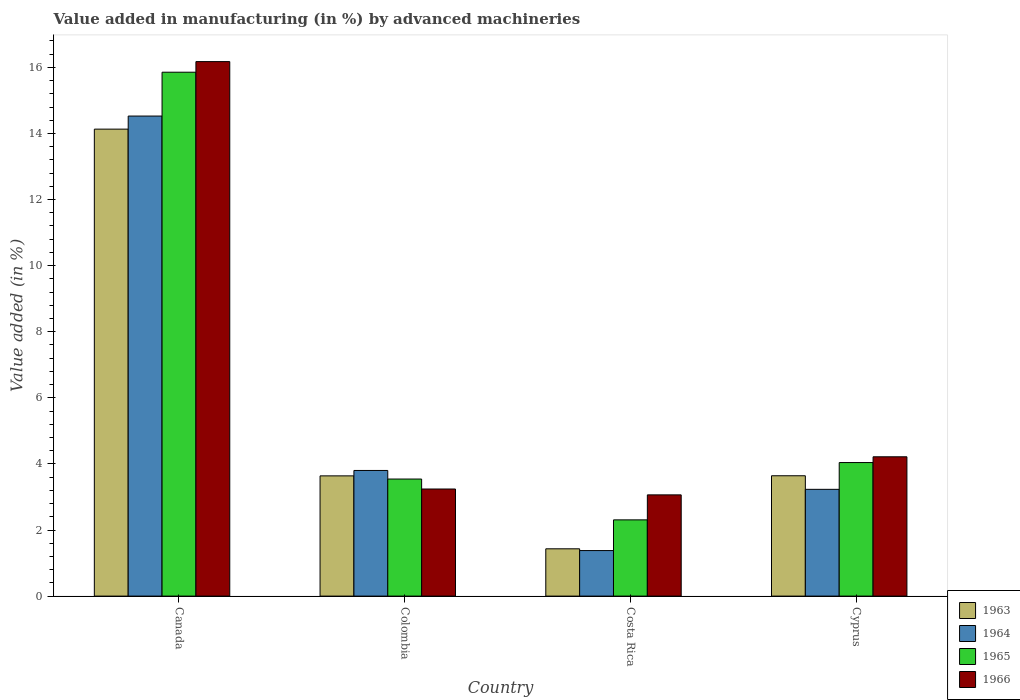Are the number of bars per tick equal to the number of legend labels?
Provide a succinct answer. Yes. Are the number of bars on each tick of the X-axis equal?
Your answer should be compact. Yes. What is the label of the 3rd group of bars from the left?
Offer a very short reply. Costa Rica. What is the percentage of value added in manufacturing by advanced machineries in 1965 in Colombia?
Keep it short and to the point. 3.54. Across all countries, what is the maximum percentage of value added in manufacturing by advanced machineries in 1966?
Keep it short and to the point. 16.17. Across all countries, what is the minimum percentage of value added in manufacturing by advanced machineries in 1964?
Keep it short and to the point. 1.38. In which country was the percentage of value added in manufacturing by advanced machineries in 1964 maximum?
Offer a terse response. Canada. What is the total percentage of value added in manufacturing by advanced machineries in 1964 in the graph?
Provide a short and direct response. 22.94. What is the difference between the percentage of value added in manufacturing by advanced machineries in 1966 in Costa Rica and that in Cyprus?
Your answer should be very brief. -1.15. What is the difference between the percentage of value added in manufacturing by advanced machineries in 1964 in Canada and the percentage of value added in manufacturing by advanced machineries in 1963 in Colombia?
Keep it short and to the point. 10.89. What is the average percentage of value added in manufacturing by advanced machineries in 1965 per country?
Give a very brief answer. 6.44. What is the difference between the percentage of value added in manufacturing by advanced machineries of/in 1965 and percentage of value added in manufacturing by advanced machineries of/in 1966 in Canada?
Ensure brevity in your answer.  -0.32. In how many countries, is the percentage of value added in manufacturing by advanced machineries in 1963 greater than 2 %?
Offer a very short reply. 3. What is the ratio of the percentage of value added in manufacturing by advanced machineries in 1966 in Colombia to that in Cyprus?
Make the answer very short. 0.77. Is the difference between the percentage of value added in manufacturing by advanced machineries in 1965 in Costa Rica and Cyprus greater than the difference between the percentage of value added in manufacturing by advanced machineries in 1966 in Costa Rica and Cyprus?
Provide a succinct answer. No. What is the difference between the highest and the second highest percentage of value added in manufacturing by advanced machineries in 1964?
Your answer should be compact. -0.57. What is the difference between the highest and the lowest percentage of value added in manufacturing by advanced machineries in 1964?
Make the answer very short. 13.15. In how many countries, is the percentage of value added in manufacturing by advanced machineries in 1966 greater than the average percentage of value added in manufacturing by advanced machineries in 1966 taken over all countries?
Your response must be concise. 1. Is it the case that in every country, the sum of the percentage of value added in manufacturing by advanced machineries in 1965 and percentage of value added in manufacturing by advanced machineries in 1966 is greater than the sum of percentage of value added in manufacturing by advanced machineries in 1963 and percentage of value added in manufacturing by advanced machineries in 1964?
Your response must be concise. No. What does the 1st bar from the right in Colombia represents?
Make the answer very short. 1966. How many bars are there?
Ensure brevity in your answer.  16. How many countries are there in the graph?
Provide a short and direct response. 4. Are the values on the major ticks of Y-axis written in scientific E-notation?
Provide a short and direct response. No. Does the graph contain any zero values?
Offer a very short reply. No. Does the graph contain grids?
Your answer should be compact. No. Where does the legend appear in the graph?
Provide a short and direct response. Bottom right. How many legend labels are there?
Provide a short and direct response. 4. What is the title of the graph?
Offer a very short reply. Value added in manufacturing (in %) by advanced machineries. Does "2012" appear as one of the legend labels in the graph?
Offer a terse response. No. What is the label or title of the Y-axis?
Offer a very short reply. Value added (in %). What is the Value added (in %) of 1963 in Canada?
Keep it short and to the point. 14.13. What is the Value added (in %) in 1964 in Canada?
Give a very brief answer. 14.53. What is the Value added (in %) of 1965 in Canada?
Your response must be concise. 15.85. What is the Value added (in %) in 1966 in Canada?
Offer a terse response. 16.17. What is the Value added (in %) in 1963 in Colombia?
Provide a short and direct response. 3.64. What is the Value added (in %) of 1964 in Colombia?
Your answer should be very brief. 3.8. What is the Value added (in %) of 1965 in Colombia?
Keep it short and to the point. 3.54. What is the Value added (in %) of 1966 in Colombia?
Provide a succinct answer. 3.24. What is the Value added (in %) of 1963 in Costa Rica?
Your answer should be very brief. 1.43. What is the Value added (in %) in 1964 in Costa Rica?
Your answer should be compact. 1.38. What is the Value added (in %) in 1965 in Costa Rica?
Ensure brevity in your answer.  2.31. What is the Value added (in %) of 1966 in Costa Rica?
Provide a succinct answer. 3.06. What is the Value added (in %) of 1963 in Cyprus?
Provide a succinct answer. 3.64. What is the Value added (in %) of 1964 in Cyprus?
Offer a very short reply. 3.23. What is the Value added (in %) of 1965 in Cyprus?
Keep it short and to the point. 4.04. What is the Value added (in %) in 1966 in Cyprus?
Give a very brief answer. 4.22. Across all countries, what is the maximum Value added (in %) in 1963?
Provide a succinct answer. 14.13. Across all countries, what is the maximum Value added (in %) in 1964?
Your answer should be very brief. 14.53. Across all countries, what is the maximum Value added (in %) of 1965?
Offer a terse response. 15.85. Across all countries, what is the maximum Value added (in %) in 1966?
Keep it short and to the point. 16.17. Across all countries, what is the minimum Value added (in %) of 1963?
Provide a short and direct response. 1.43. Across all countries, what is the minimum Value added (in %) of 1964?
Your answer should be very brief. 1.38. Across all countries, what is the minimum Value added (in %) in 1965?
Make the answer very short. 2.31. Across all countries, what is the minimum Value added (in %) of 1966?
Keep it short and to the point. 3.06. What is the total Value added (in %) in 1963 in the graph?
Offer a very short reply. 22.84. What is the total Value added (in %) in 1964 in the graph?
Offer a very short reply. 22.94. What is the total Value added (in %) in 1965 in the graph?
Your answer should be very brief. 25.74. What is the total Value added (in %) in 1966 in the graph?
Your answer should be very brief. 26.69. What is the difference between the Value added (in %) in 1963 in Canada and that in Colombia?
Provide a short and direct response. 10.49. What is the difference between the Value added (in %) of 1964 in Canada and that in Colombia?
Ensure brevity in your answer.  10.72. What is the difference between the Value added (in %) in 1965 in Canada and that in Colombia?
Your answer should be very brief. 12.31. What is the difference between the Value added (in %) of 1966 in Canada and that in Colombia?
Offer a terse response. 12.93. What is the difference between the Value added (in %) in 1963 in Canada and that in Costa Rica?
Make the answer very short. 12.7. What is the difference between the Value added (in %) in 1964 in Canada and that in Costa Rica?
Your response must be concise. 13.15. What is the difference between the Value added (in %) in 1965 in Canada and that in Costa Rica?
Your answer should be very brief. 13.55. What is the difference between the Value added (in %) in 1966 in Canada and that in Costa Rica?
Give a very brief answer. 13.11. What is the difference between the Value added (in %) of 1963 in Canada and that in Cyprus?
Your answer should be compact. 10.49. What is the difference between the Value added (in %) of 1964 in Canada and that in Cyprus?
Ensure brevity in your answer.  11.3. What is the difference between the Value added (in %) of 1965 in Canada and that in Cyprus?
Offer a terse response. 11.81. What is the difference between the Value added (in %) in 1966 in Canada and that in Cyprus?
Offer a very short reply. 11.96. What is the difference between the Value added (in %) in 1963 in Colombia and that in Costa Rica?
Provide a succinct answer. 2.21. What is the difference between the Value added (in %) in 1964 in Colombia and that in Costa Rica?
Ensure brevity in your answer.  2.42. What is the difference between the Value added (in %) of 1965 in Colombia and that in Costa Rica?
Offer a very short reply. 1.24. What is the difference between the Value added (in %) of 1966 in Colombia and that in Costa Rica?
Ensure brevity in your answer.  0.18. What is the difference between the Value added (in %) in 1963 in Colombia and that in Cyprus?
Provide a short and direct response. -0. What is the difference between the Value added (in %) of 1964 in Colombia and that in Cyprus?
Your answer should be very brief. 0.57. What is the difference between the Value added (in %) of 1965 in Colombia and that in Cyprus?
Offer a very short reply. -0.5. What is the difference between the Value added (in %) of 1966 in Colombia and that in Cyprus?
Provide a short and direct response. -0.97. What is the difference between the Value added (in %) in 1963 in Costa Rica and that in Cyprus?
Give a very brief answer. -2.21. What is the difference between the Value added (in %) in 1964 in Costa Rica and that in Cyprus?
Your response must be concise. -1.85. What is the difference between the Value added (in %) of 1965 in Costa Rica and that in Cyprus?
Offer a very short reply. -1.73. What is the difference between the Value added (in %) of 1966 in Costa Rica and that in Cyprus?
Offer a terse response. -1.15. What is the difference between the Value added (in %) in 1963 in Canada and the Value added (in %) in 1964 in Colombia?
Your response must be concise. 10.33. What is the difference between the Value added (in %) of 1963 in Canada and the Value added (in %) of 1965 in Colombia?
Provide a short and direct response. 10.59. What is the difference between the Value added (in %) of 1963 in Canada and the Value added (in %) of 1966 in Colombia?
Keep it short and to the point. 10.89. What is the difference between the Value added (in %) of 1964 in Canada and the Value added (in %) of 1965 in Colombia?
Provide a succinct answer. 10.98. What is the difference between the Value added (in %) in 1964 in Canada and the Value added (in %) in 1966 in Colombia?
Make the answer very short. 11.29. What is the difference between the Value added (in %) in 1965 in Canada and the Value added (in %) in 1966 in Colombia?
Provide a short and direct response. 12.61. What is the difference between the Value added (in %) in 1963 in Canada and the Value added (in %) in 1964 in Costa Rica?
Provide a succinct answer. 12.75. What is the difference between the Value added (in %) in 1963 in Canada and the Value added (in %) in 1965 in Costa Rica?
Give a very brief answer. 11.82. What is the difference between the Value added (in %) in 1963 in Canada and the Value added (in %) in 1966 in Costa Rica?
Your response must be concise. 11.07. What is the difference between the Value added (in %) in 1964 in Canada and the Value added (in %) in 1965 in Costa Rica?
Provide a short and direct response. 12.22. What is the difference between the Value added (in %) in 1964 in Canada and the Value added (in %) in 1966 in Costa Rica?
Keep it short and to the point. 11.46. What is the difference between the Value added (in %) of 1965 in Canada and the Value added (in %) of 1966 in Costa Rica?
Offer a terse response. 12.79. What is the difference between the Value added (in %) of 1963 in Canada and the Value added (in %) of 1964 in Cyprus?
Make the answer very short. 10.9. What is the difference between the Value added (in %) in 1963 in Canada and the Value added (in %) in 1965 in Cyprus?
Provide a succinct answer. 10.09. What is the difference between the Value added (in %) in 1963 in Canada and the Value added (in %) in 1966 in Cyprus?
Give a very brief answer. 9.92. What is the difference between the Value added (in %) in 1964 in Canada and the Value added (in %) in 1965 in Cyprus?
Your response must be concise. 10.49. What is the difference between the Value added (in %) of 1964 in Canada and the Value added (in %) of 1966 in Cyprus?
Your answer should be compact. 10.31. What is the difference between the Value added (in %) in 1965 in Canada and the Value added (in %) in 1966 in Cyprus?
Your response must be concise. 11.64. What is the difference between the Value added (in %) of 1963 in Colombia and the Value added (in %) of 1964 in Costa Rica?
Make the answer very short. 2.26. What is the difference between the Value added (in %) of 1963 in Colombia and the Value added (in %) of 1965 in Costa Rica?
Your response must be concise. 1.33. What is the difference between the Value added (in %) of 1963 in Colombia and the Value added (in %) of 1966 in Costa Rica?
Keep it short and to the point. 0.57. What is the difference between the Value added (in %) of 1964 in Colombia and the Value added (in %) of 1965 in Costa Rica?
Provide a succinct answer. 1.49. What is the difference between the Value added (in %) in 1964 in Colombia and the Value added (in %) in 1966 in Costa Rica?
Offer a very short reply. 0.74. What is the difference between the Value added (in %) in 1965 in Colombia and the Value added (in %) in 1966 in Costa Rica?
Keep it short and to the point. 0.48. What is the difference between the Value added (in %) of 1963 in Colombia and the Value added (in %) of 1964 in Cyprus?
Offer a very short reply. 0.41. What is the difference between the Value added (in %) of 1963 in Colombia and the Value added (in %) of 1965 in Cyprus?
Ensure brevity in your answer.  -0.4. What is the difference between the Value added (in %) of 1963 in Colombia and the Value added (in %) of 1966 in Cyprus?
Provide a succinct answer. -0.58. What is the difference between the Value added (in %) of 1964 in Colombia and the Value added (in %) of 1965 in Cyprus?
Your answer should be compact. -0.24. What is the difference between the Value added (in %) in 1964 in Colombia and the Value added (in %) in 1966 in Cyprus?
Keep it short and to the point. -0.41. What is the difference between the Value added (in %) of 1965 in Colombia and the Value added (in %) of 1966 in Cyprus?
Your response must be concise. -0.67. What is the difference between the Value added (in %) of 1963 in Costa Rica and the Value added (in %) of 1964 in Cyprus?
Your answer should be compact. -1.8. What is the difference between the Value added (in %) of 1963 in Costa Rica and the Value added (in %) of 1965 in Cyprus?
Offer a terse response. -2.61. What is the difference between the Value added (in %) of 1963 in Costa Rica and the Value added (in %) of 1966 in Cyprus?
Make the answer very short. -2.78. What is the difference between the Value added (in %) in 1964 in Costa Rica and the Value added (in %) in 1965 in Cyprus?
Your response must be concise. -2.66. What is the difference between the Value added (in %) in 1964 in Costa Rica and the Value added (in %) in 1966 in Cyprus?
Your answer should be very brief. -2.84. What is the difference between the Value added (in %) in 1965 in Costa Rica and the Value added (in %) in 1966 in Cyprus?
Offer a very short reply. -1.91. What is the average Value added (in %) of 1963 per country?
Your answer should be compact. 5.71. What is the average Value added (in %) of 1964 per country?
Keep it short and to the point. 5.73. What is the average Value added (in %) of 1965 per country?
Provide a succinct answer. 6.44. What is the average Value added (in %) in 1966 per country?
Your answer should be very brief. 6.67. What is the difference between the Value added (in %) in 1963 and Value added (in %) in 1964 in Canada?
Your answer should be very brief. -0.4. What is the difference between the Value added (in %) in 1963 and Value added (in %) in 1965 in Canada?
Give a very brief answer. -1.72. What is the difference between the Value added (in %) of 1963 and Value added (in %) of 1966 in Canada?
Offer a terse response. -2.04. What is the difference between the Value added (in %) of 1964 and Value added (in %) of 1965 in Canada?
Keep it short and to the point. -1.33. What is the difference between the Value added (in %) in 1964 and Value added (in %) in 1966 in Canada?
Give a very brief answer. -1.65. What is the difference between the Value added (in %) of 1965 and Value added (in %) of 1966 in Canada?
Ensure brevity in your answer.  -0.32. What is the difference between the Value added (in %) of 1963 and Value added (in %) of 1964 in Colombia?
Give a very brief answer. -0.16. What is the difference between the Value added (in %) in 1963 and Value added (in %) in 1965 in Colombia?
Your answer should be very brief. 0.1. What is the difference between the Value added (in %) in 1963 and Value added (in %) in 1966 in Colombia?
Keep it short and to the point. 0.4. What is the difference between the Value added (in %) of 1964 and Value added (in %) of 1965 in Colombia?
Provide a succinct answer. 0.26. What is the difference between the Value added (in %) in 1964 and Value added (in %) in 1966 in Colombia?
Give a very brief answer. 0.56. What is the difference between the Value added (in %) of 1965 and Value added (in %) of 1966 in Colombia?
Make the answer very short. 0.3. What is the difference between the Value added (in %) in 1963 and Value added (in %) in 1964 in Costa Rica?
Provide a short and direct response. 0.05. What is the difference between the Value added (in %) in 1963 and Value added (in %) in 1965 in Costa Rica?
Your answer should be very brief. -0.88. What is the difference between the Value added (in %) of 1963 and Value added (in %) of 1966 in Costa Rica?
Your answer should be very brief. -1.63. What is the difference between the Value added (in %) of 1964 and Value added (in %) of 1965 in Costa Rica?
Offer a terse response. -0.93. What is the difference between the Value added (in %) in 1964 and Value added (in %) in 1966 in Costa Rica?
Your answer should be compact. -1.69. What is the difference between the Value added (in %) of 1965 and Value added (in %) of 1966 in Costa Rica?
Your response must be concise. -0.76. What is the difference between the Value added (in %) of 1963 and Value added (in %) of 1964 in Cyprus?
Provide a short and direct response. 0.41. What is the difference between the Value added (in %) of 1963 and Value added (in %) of 1965 in Cyprus?
Provide a succinct answer. -0.4. What is the difference between the Value added (in %) of 1963 and Value added (in %) of 1966 in Cyprus?
Offer a very short reply. -0.57. What is the difference between the Value added (in %) of 1964 and Value added (in %) of 1965 in Cyprus?
Your response must be concise. -0.81. What is the difference between the Value added (in %) of 1964 and Value added (in %) of 1966 in Cyprus?
Provide a short and direct response. -0.98. What is the difference between the Value added (in %) of 1965 and Value added (in %) of 1966 in Cyprus?
Ensure brevity in your answer.  -0.17. What is the ratio of the Value added (in %) in 1963 in Canada to that in Colombia?
Make the answer very short. 3.88. What is the ratio of the Value added (in %) of 1964 in Canada to that in Colombia?
Make the answer very short. 3.82. What is the ratio of the Value added (in %) of 1965 in Canada to that in Colombia?
Your response must be concise. 4.48. What is the ratio of the Value added (in %) of 1966 in Canada to that in Colombia?
Keep it short and to the point. 4.99. What is the ratio of the Value added (in %) in 1963 in Canada to that in Costa Rica?
Make the answer very short. 9.87. What is the ratio of the Value added (in %) in 1964 in Canada to that in Costa Rica?
Give a very brief answer. 10.54. What is the ratio of the Value added (in %) in 1965 in Canada to that in Costa Rica?
Provide a succinct answer. 6.87. What is the ratio of the Value added (in %) of 1966 in Canada to that in Costa Rica?
Give a very brief answer. 5.28. What is the ratio of the Value added (in %) of 1963 in Canada to that in Cyprus?
Give a very brief answer. 3.88. What is the ratio of the Value added (in %) in 1964 in Canada to that in Cyprus?
Provide a succinct answer. 4.5. What is the ratio of the Value added (in %) in 1965 in Canada to that in Cyprus?
Your answer should be compact. 3.92. What is the ratio of the Value added (in %) of 1966 in Canada to that in Cyprus?
Your answer should be compact. 3.84. What is the ratio of the Value added (in %) of 1963 in Colombia to that in Costa Rica?
Offer a terse response. 2.54. What is the ratio of the Value added (in %) in 1964 in Colombia to that in Costa Rica?
Provide a short and direct response. 2.76. What is the ratio of the Value added (in %) in 1965 in Colombia to that in Costa Rica?
Offer a terse response. 1.54. What is the ratio of the Value added (in %) in 1966 in Colombia to that in Costa Rica?
Your answer should be compact. 1.06. What is the ratio of the Value added (in %) in 1964 in Colombia to that in Cyprus?
Make the answer very short. 1.18. What is the ratio of the Value added (in %) in 1965 in Colombia to that in Cyprus?
Provide a short and direct response. 0.88. What is the ratio of the Value added (in %) in 1966 in Colombia to that in Cyprus?
Offer a very short reply. 0.77. What is the ratio of the Value added (in %) of 1963 in Costa Rica to that in Cyprus?
Your response must be concise. 0.39. What is the ratio of the Value added (in %) in 1964 in Costa Rica to that in Cyprus?
Your response must be concise. 0.43. What is the ratio of the Value added (in %) in 1965 in Costa Rica to that in Cyprus?
Keep it short and to the point. 0.57. What is the ratio of the Value added (in %) of 1966 in Costa Rica to that in Cyprus?
Offer a very short reply. 0.73. What is the difference between the highest and the second highest Value added (in %) of 1963?
Offer a very short reply. 10.49. What is the difference between the highest and the second highest Value added (in %) of 1964?
Ensure brevity in your answer.  10.72. What is the difference between the highest and the second highest Value added (in %) in 1965?
Give a very brief answer. 11.81. What is the difference between the highest and the second highest Value added (in %) of 1966?
Ensure brevity in your answer.  11.96. What is the difference between the highest and the lowest Value added (in %) of 1963?
Your answer should be very brief. 12.7. What is the difference between the highest and the lowest Value added (in %) of 1964?
Offer a terse response. 13.15. What is the difference between the highest and the lowest Value added (in %) in 1965?
Your answer should be very brief. 13.55. What is the difference between the highest and the lowest Value added (in %) in 1966?
Offer a very short reply. 13.11. 